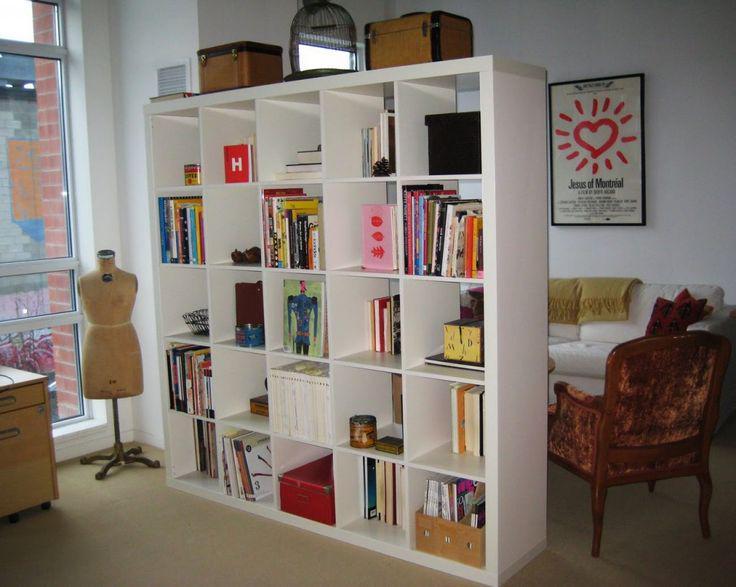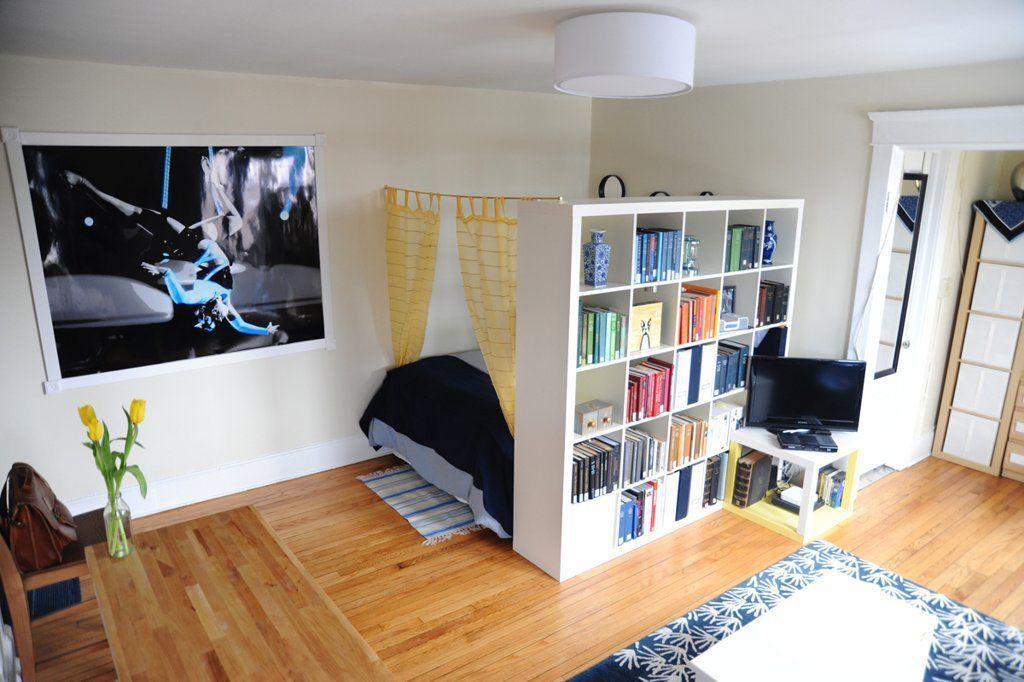The first image is the image on the left, the second image is the image on the right. Evaluate the accuracy of this statement regarding the images: "In each image, a wide white shelving unit is placed perpendicular to a wall to create a room divider.". Is it true? Answer yes or no. Yes. The first image is the image on the left, the second image is the image on the right. Given the left and right images, does the statement "One of the bookshelves has decorative items on top as well as on the shelves." hold true? Answer yes or no. Yes. 